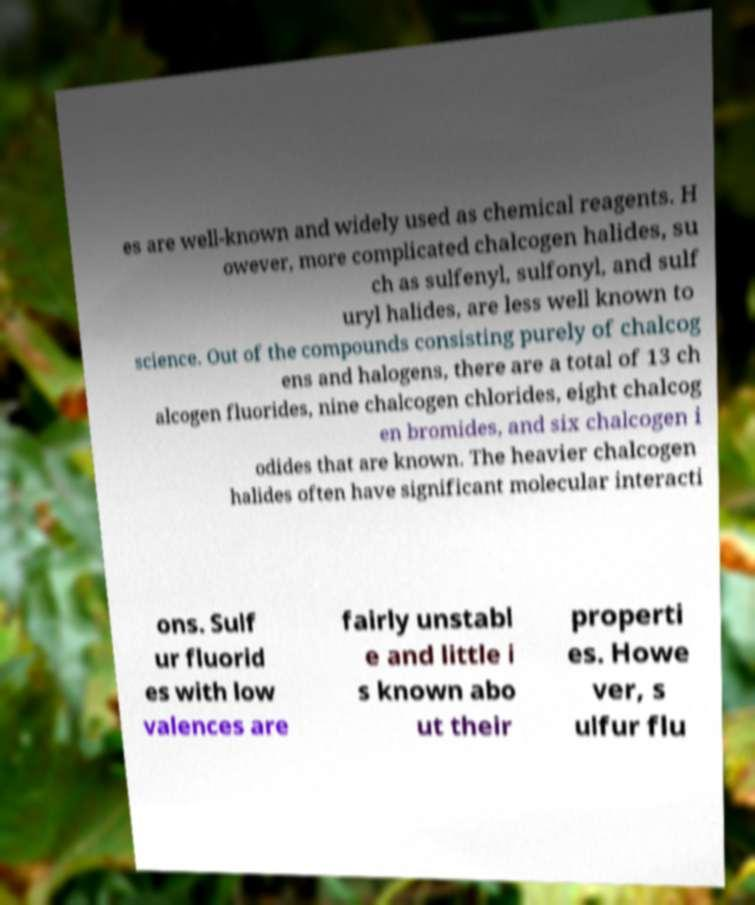Please read and relay the text visible in this image. What does it say? es are well-known and widely used as chemical reagents. H owever, more complicated chalcogen halides, su ch as sulfenyl, sulfonyl, and sulf uryl halides, are less well known to science. Out of the compounds consisting purely of chalcog ens and halogens, there are a total of 13 ch alcogen fluorides, nine chalcogen chlorides, eight chalcog en bromides, and six chalcogen i odides that are known. The heavier chalcogen halides often have significant molecular interacti ons. Sulf ur fluorid es with low valences are fairly unstabl e and little i s known abo ut their properti es. Howe ver, s ulfur flu 